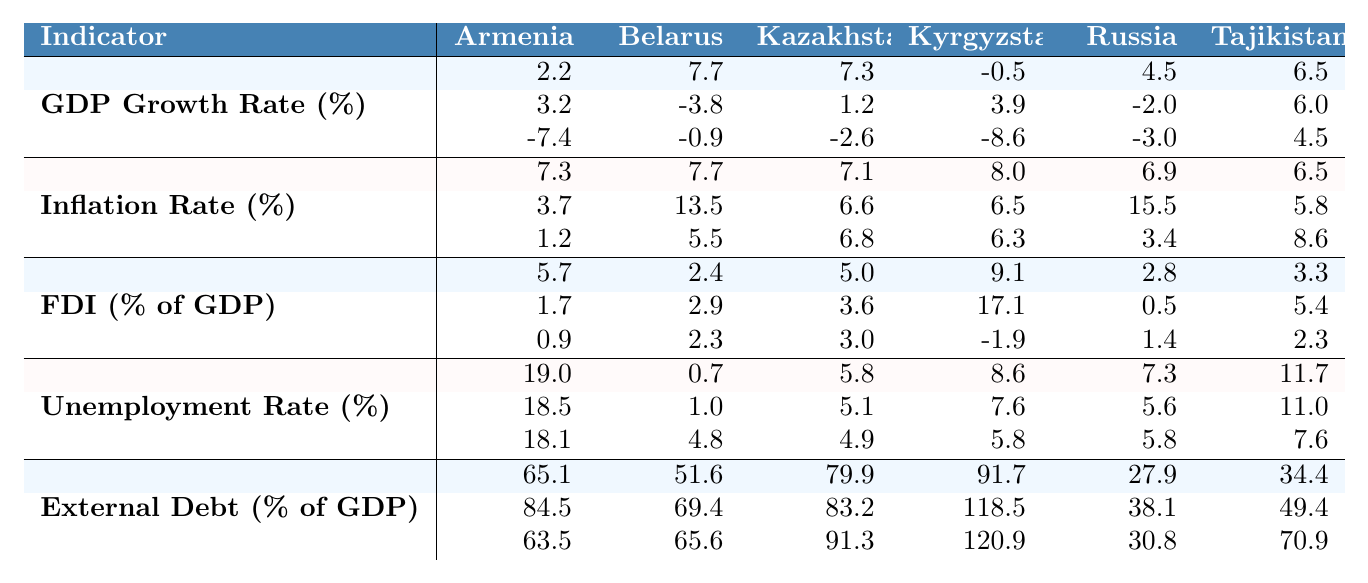What was Armenia's GDP growth rate in 2010? The table shows the GDP growth rate for Armenia in 2010 as 2.2%.
Answer: 2.2% What was the highest GDP growth rate recorded for Belarus across the years listed? The GDP growth rate for Belarus peaked at 7.7% in 2010, the highest among the recorded years.
Answer: 7.7% How did Armenia's unemployment rate change from 2015 to 2020? In 2015, Armenia's unemployment rate was 18.5%, and in 2020 it decreased slightly to 18.1%. The change is calculated as 18.1% - 18.5% = -0.4%.
Answer: Decrease of 0.4% Which country had the highest inflation rate in 2015? The inflation rate for Belarus was the highest in 2015 at 13.5%.
Answer: 13.5% What was the average foreign direct investment (FDI) as a percentage of GDP for Kazakhstan from 2010 to 2020? The FDI for Kazakhstan was 5.0% in 2010, 3.6% in 2015, and 3.0% in 2020. The average is (5.0 + 3.6 + 3.0) / 3 = 11.6 / 3 = 3.87%.
Answer: 3.87% Did Kyrgyzstan have a higher external debt percentage in 2020 than in 2015? In 2015, Kyrgyzstan had 118.5% external debt, which is greater than the 120.9% in 2020, indicating that it has increased.
Answer: Yes How does the 2020 GDP growth rate of Armenia compare to that of Tajikistan? Armenia's GDP growth rate in 2020 was -7.4%, while Tajikistan's was +4.5%. Tajikistan's rate is higher.
Answer: Tajikistan is higher What is the difference in the unemployment rate of Russia from 2010 to 2020? Russia's unemployment rates were 7.3% in 2010 and 5.8% in 2020. The difference is 7.3% - 5.8% = 1.5%.
Answer: 1.5% Which country had the lowest foreign direct investment as a percentage of GDP in 2020? In 2020, Armenia had the lowest foreign direct investment at 0.9%.
Answer: 0.9% Which country saw the most significant drop in GDP growth rate from 2015 to 2020? Armenia saw the most significant drop from 3.2% in 2015 to -7.4% in 2020, a change of -10.6%.
Answer: Armenia Was there a rise in the inflation rate for Tajikistan from 2015 to 2020? Tajikistan's inflation rate decreased from 5.8% in 2015 to 8.6% in 2020, indicating a rise.
Answer: Yes 